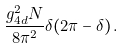Convert formula to latex. <formula><loc_0><loc_0><loc_500><loc_500>\frac { g _ { 4 d } ^ { 2 } N } { 8 \pi ^ { 2 } } \delta ( 2 \pi - \delta ) \, .</formula> 